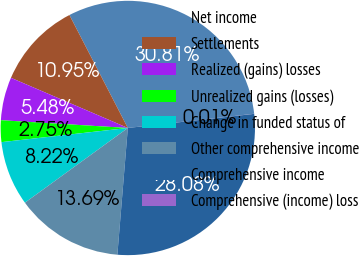Convert chart to OTSL. <chart><loc_0><loc_0><loc_500><loc_500><pie_chart><fcel>Net income<fcel>Settlements<fcel>Realized (gains) losses<fcel>Unrealized gains (losses)<fcel>Change in funded status of<fcel>Other comprehensive income<fcel>Comprehensive income<fcel>Comprehensive (income) loss<nl><fcel>30.81%<fcel>10.95%<fcel>5.48%<fcel>2.75%<fcel>8.22%<fcel>13.69%<fcel>28.08%<fcel>0.01%<nl></chart> 